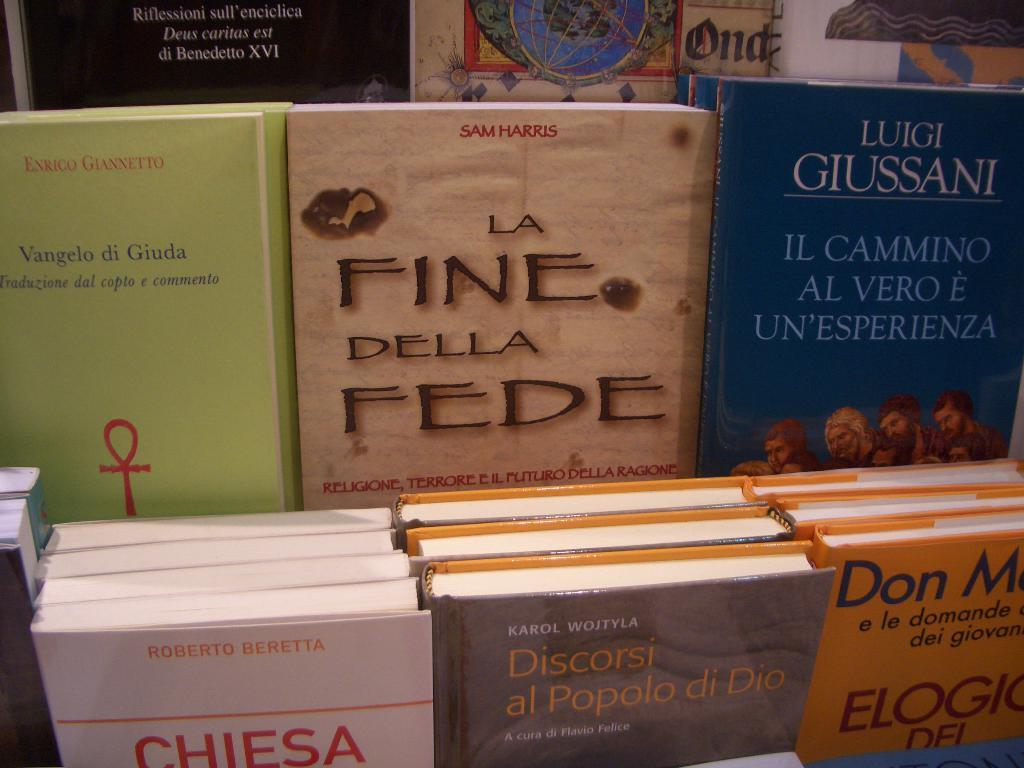<image>
Offer a succinct explanation of the picture presented. A book by Sam Harris is near other books. 